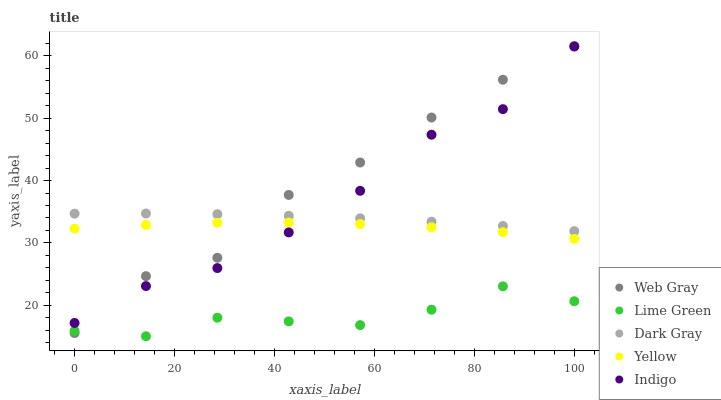Does Lime Green have the minimum area under the curve?
Answer yes or no. Yes. Does Web Gray have the maximum area under the curve?
Answer yes or no. Yes. Does Indigo have the minimum area under the curve?
Answer yes or no. No. Does Indigo have the maximum area under the curve?
Answer yes or no. No. Is Dark Gray the smoothest?
Answer yes or no. Yes. Is Web Gray the roughest?
Answer yes or no. Yes. Is Indigo the smoothest?
Answer yes or no. No. Is Indigo the roughest?
Answer yes or no. No. Does Lime Green have the lowest value?
Answer yes or no. Yes. Does Indigo have the lowest value?
Answer yes or no. No. Does Web Gray have the highest value?
Answer yes or no. Yes. Does Indigo have the highest value?
Answer yes or no. No. Is Yellow less than Dark Gray?
Answer yes or no. Yes. Is Indigo greater than Lime Green?
Answer yes or no. Yes. Does Yellow intersect Indigo?
Answer yes or no. Yes. Is Yellow less than Indigo?
Answer yes or no. No. Is Yellow greater than Indigo?
Answer yes or no. No. Does Yellow intersect Dark Gray?
Answer yes or no. No. 